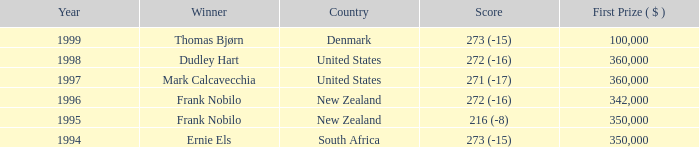What was the top first place prize in 1997? 360000.0. 